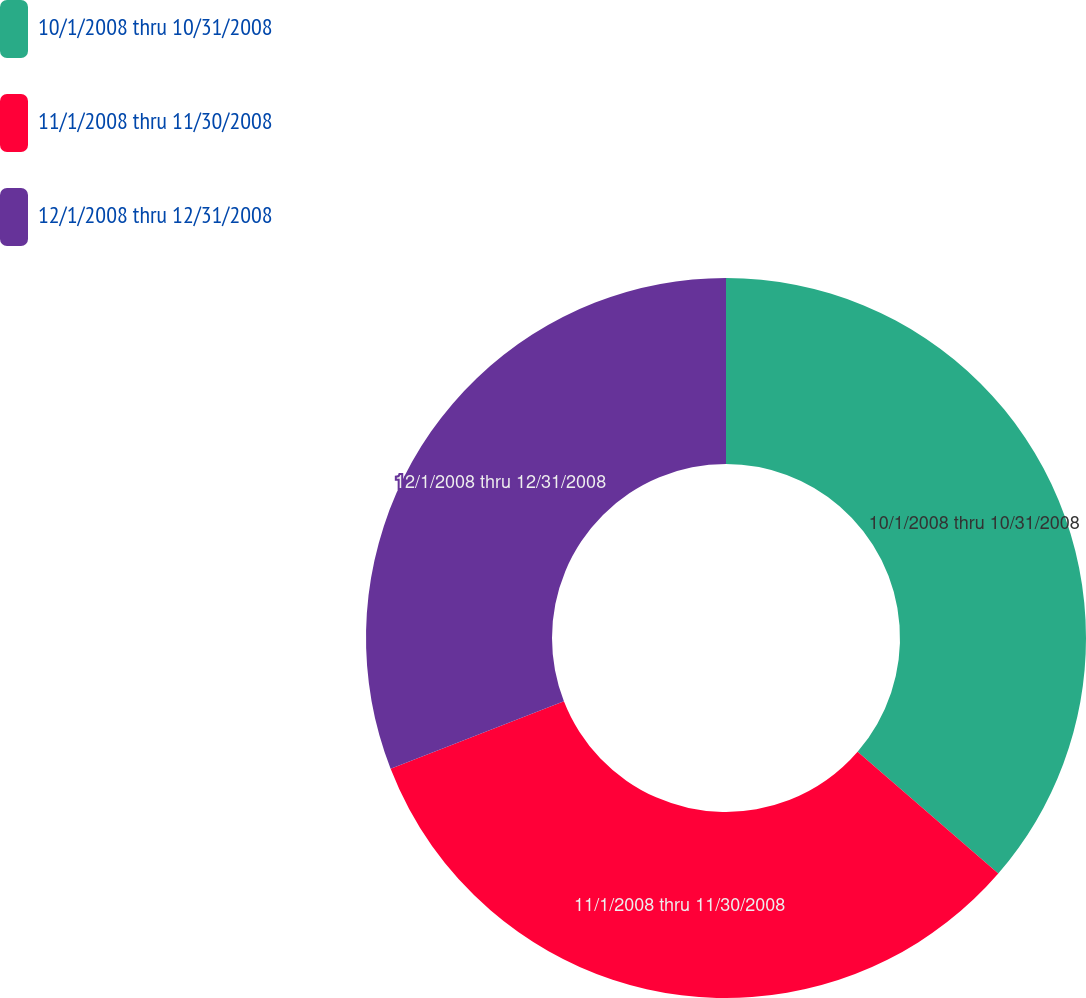Convert chart to OTSL. <chart><loc_0><loc_0><loc_500><loc_500><pie_chart><fcel>10/1/2008 thru 10/31/2008<fcel>11/1/2008 thru 11/30/2008<fcel>12/1/2008 thru 12/31/2008<nl><fcel>36.35%<fcel>32.73%<fcel>30.92%<nl></chart> 